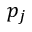<formula> <loc_0><loc_0><loc_500><loc_500>p _ { j }</formula> 